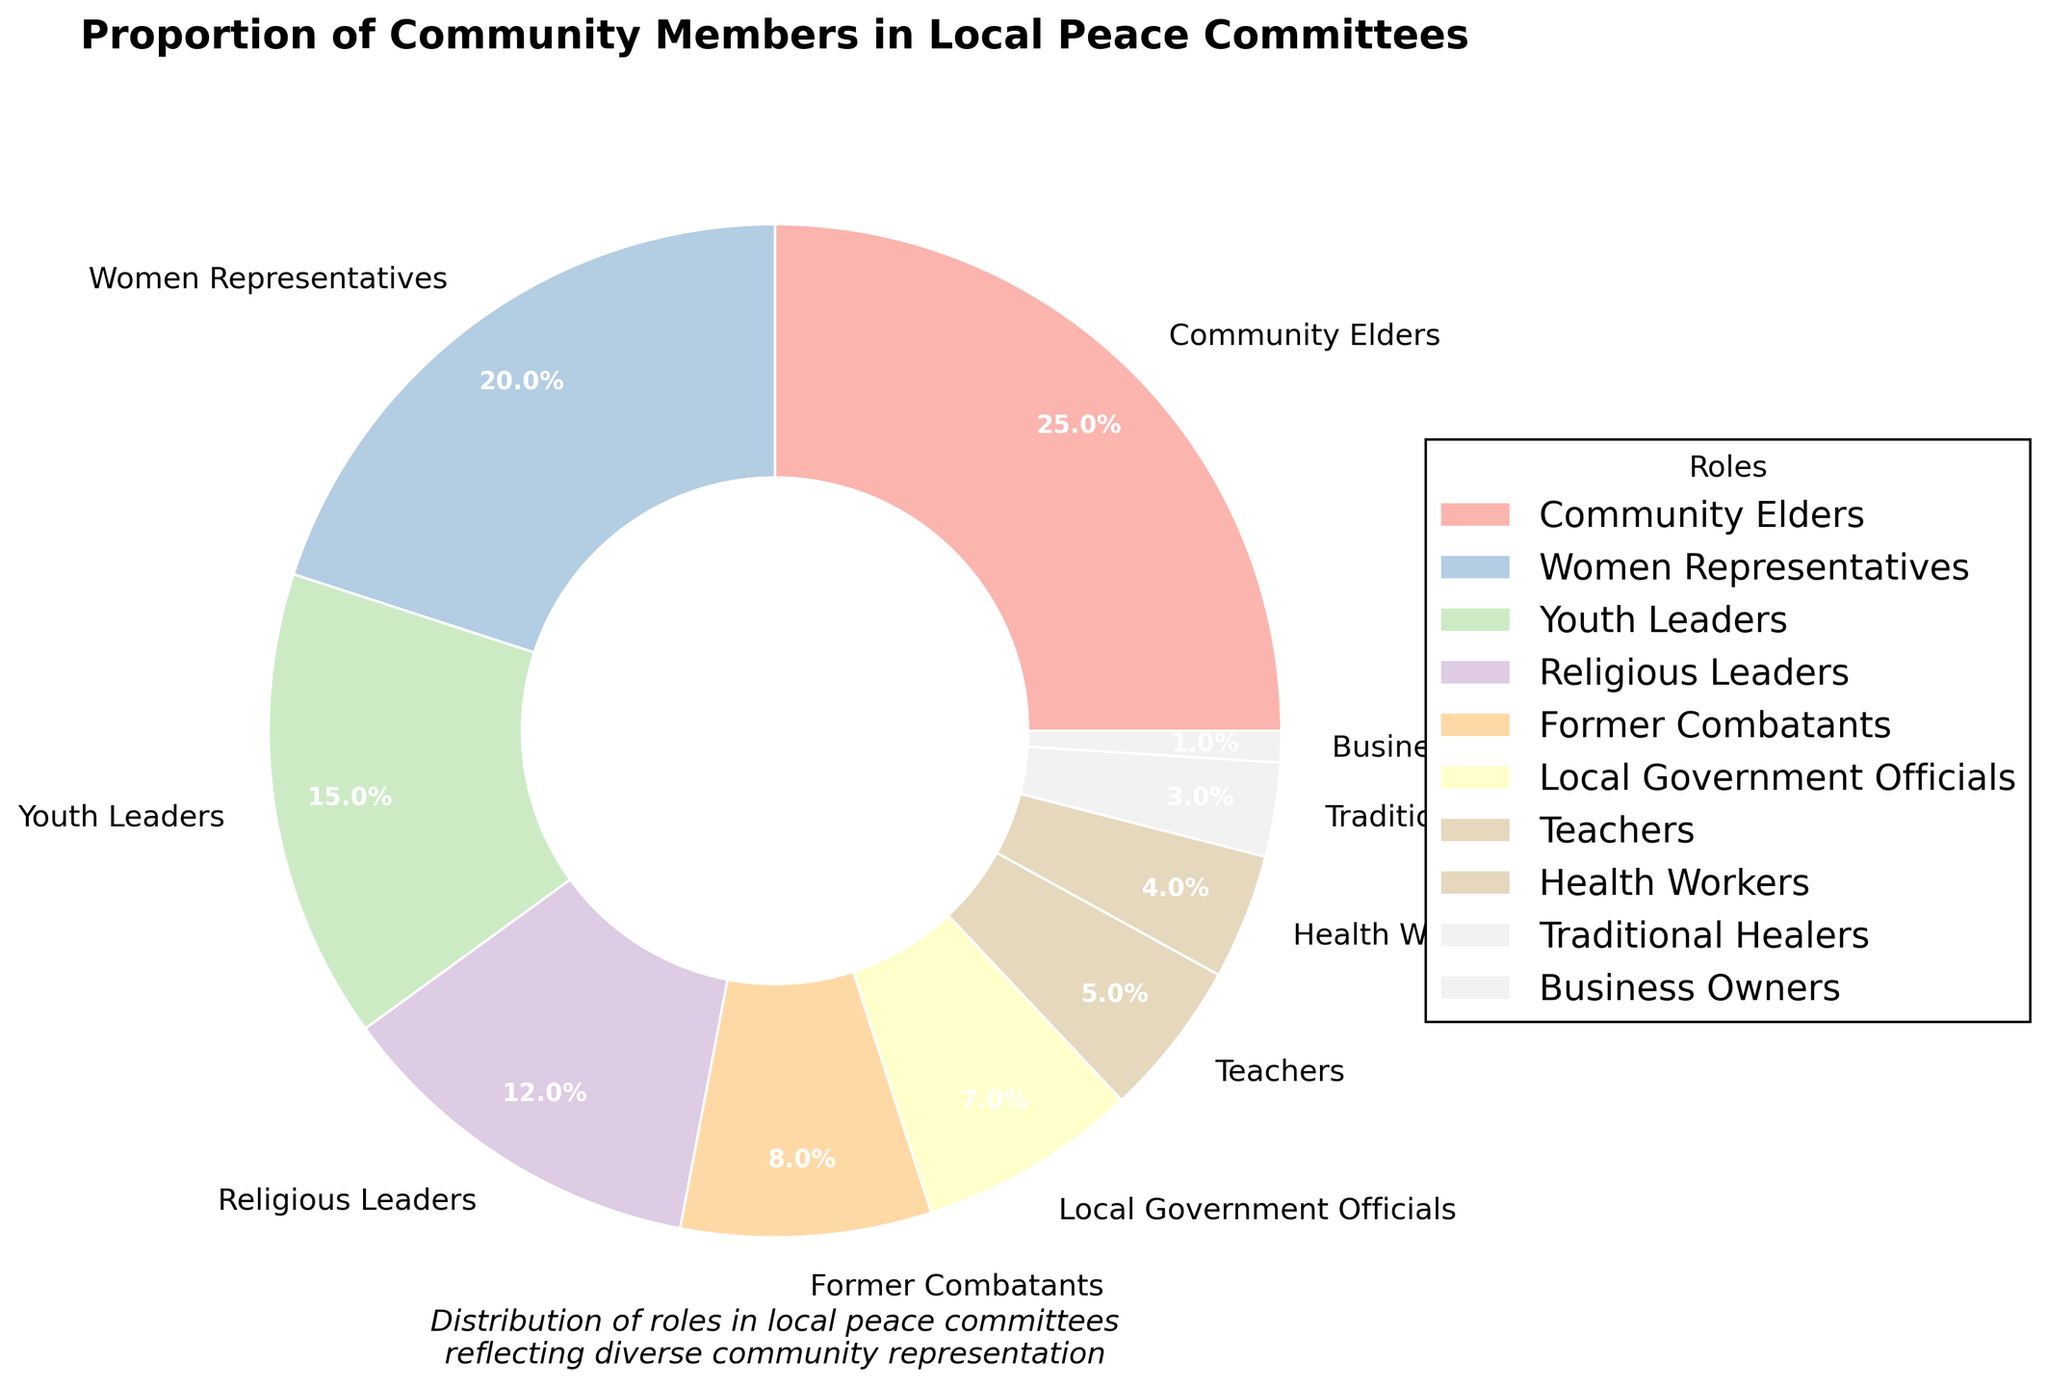Which role has the highest representation in the peace committees? The slice labeled "Community Elders" occupies the largest area in the pie chart with 25%.
Answer: Community Elders What is the combined proportion of Women Representatives and Youth Leaders? Add the percentages of Women Representatives (20%) and Youth Leaders (15%). The combined proportion is 20% + 15% = 35%.
Answer: 35% Who has a higher percentage of involvement, Religious Leaders or Former Combatants? Compare the percentages of Religious Leaders (12%) and Former Combatants (8%). 12% is greater than 8%.
Answer: Religious Leaders What is the difference in percentage between Teachers and Business Owners? Subtract the percentage of Business Owners (1%) from that of Teachers (5%). 5% - 1% = 4%.
Answer: 4% Which roles make up less than 10% each of the peace committees? Identify slices that are less than 10%. They are Former Combatants (8%), Local Government Officials (7%), Teachers (5%), Health Workers (4%), Traditional Healers (3%), and Business Owners (1%).
Answer: Former Combatants, Local Government Officials, Teachers, Health Workers, Traditional Healers, Business Owners What is the average representation of Health Workers and Traditional Healers? Add the percentages of Health Workers (4%) and Traditional Healers (3%) and divide by 2. (4% + 3%) / 2 = 3.5%.
Answer: 3.5% Are there more Youth Leaders or Local Government Officials in the peace committees, and by how much? Compare the percentages of Youth Leaders (15%) and Local Government Officials (7%). Youth Leaders have 15% - 7% = 8% more representation.
Answer: Youth Leaders by 8% What is the total percentage of all roles of Local Government Officials, Teachers, and Health Workers combined? Add the percentages of Local Government Officials (7%), Teachers (5%), and Health Workers (4%). 7% + 5% + 4% = 16%.
Answer: 16% Which role is represented by a slice that is the second-largest in the pie chart, and what is its percentage? The second-largest slice, next to Community Elders, is labeled Women Representatives with 20%.
Answer: Women Representatives, 20% Can you identify the roles that collectively form exactly half of the peace committees' composition? Determine the roles whose percentages add up to 50%. Community Elders (25%) and Women Representatives (20%) add up to 45%. Including Youth Leaders (15%) adds to 60%, requiring adjustment. Religious Leaders (12%) plus Youth Leaders (15%) add up to 27%, suggesting Community Elders (25%) and Former Combatants (8%) almost fit but overextend. Only including Community Elders at 25% leaves us under even when combined individually; thus, Community Elders (25%) + Women Representatives (20%) + Business Owners (1%) + Traditional Healers (3%) = 49%. This implies an estimate close to 50%, using a margin constraint.
Answer: Community Elders and Women Representatives with a close approximation via Business Owners and Traditional Healers 